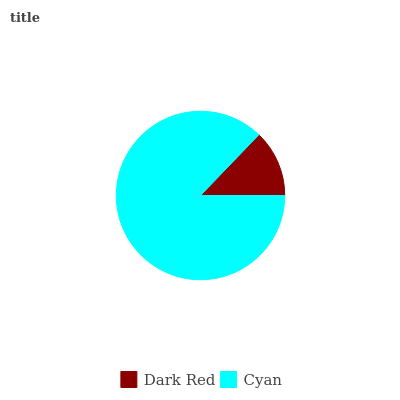Is Dark Red the minimum?
Answer yes or no. Yes. Is Cyan the maximum?
Answer yes or no. Yes. Is Cyan the minimum?
Answer yes or no. No. Is Cyan greater than Dark Red?
Answer yes or no. Yes. Is Dark Red less than Cyan?
Answer yes or no. Yes. Is Dark Red greater than Cyan?
Answer yes or no. No. Is Cyan less than Dark Red?
Answer yes or no. No. Is Cyan the high median?
Answer yes or no. Yes. Is Dark Red the low median?
Answer yes or no. Yes. Is Dark Red the high median?
Answer yes or no. No. Is Cyan the low median?
Answer yes or no. No. 